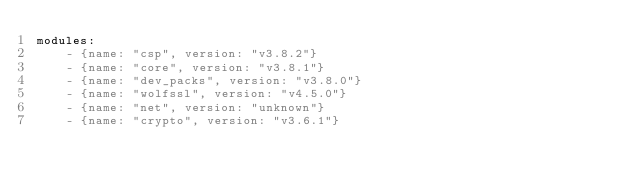Convert code to text. <code><loc_0><loc_0><loc_500><loc_500><_YAML_>modules:
    - {name: "csp", version: "v3.8.2"}
    - {name: "core", version: "v3.8.1"}
    - {name: "dev_packs", version: "v3.8.0"}
    - {name: "wolfssl", version: "v4.5.0"}
    - {name: "net", version: "unknown"}
    - {name: "crypto", version: "v3.6.1"}

</code> 